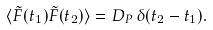<formula> <loc_0><loc_0><loc_500><loc_500>\langle \tilde { F } ( t _ { 1 } ) \tilde { F } ( t _ { 2 } ) \rangle = D _ { P } \, \delta ( t _ { 2 } - t _ { 1 } ) .</formula> 